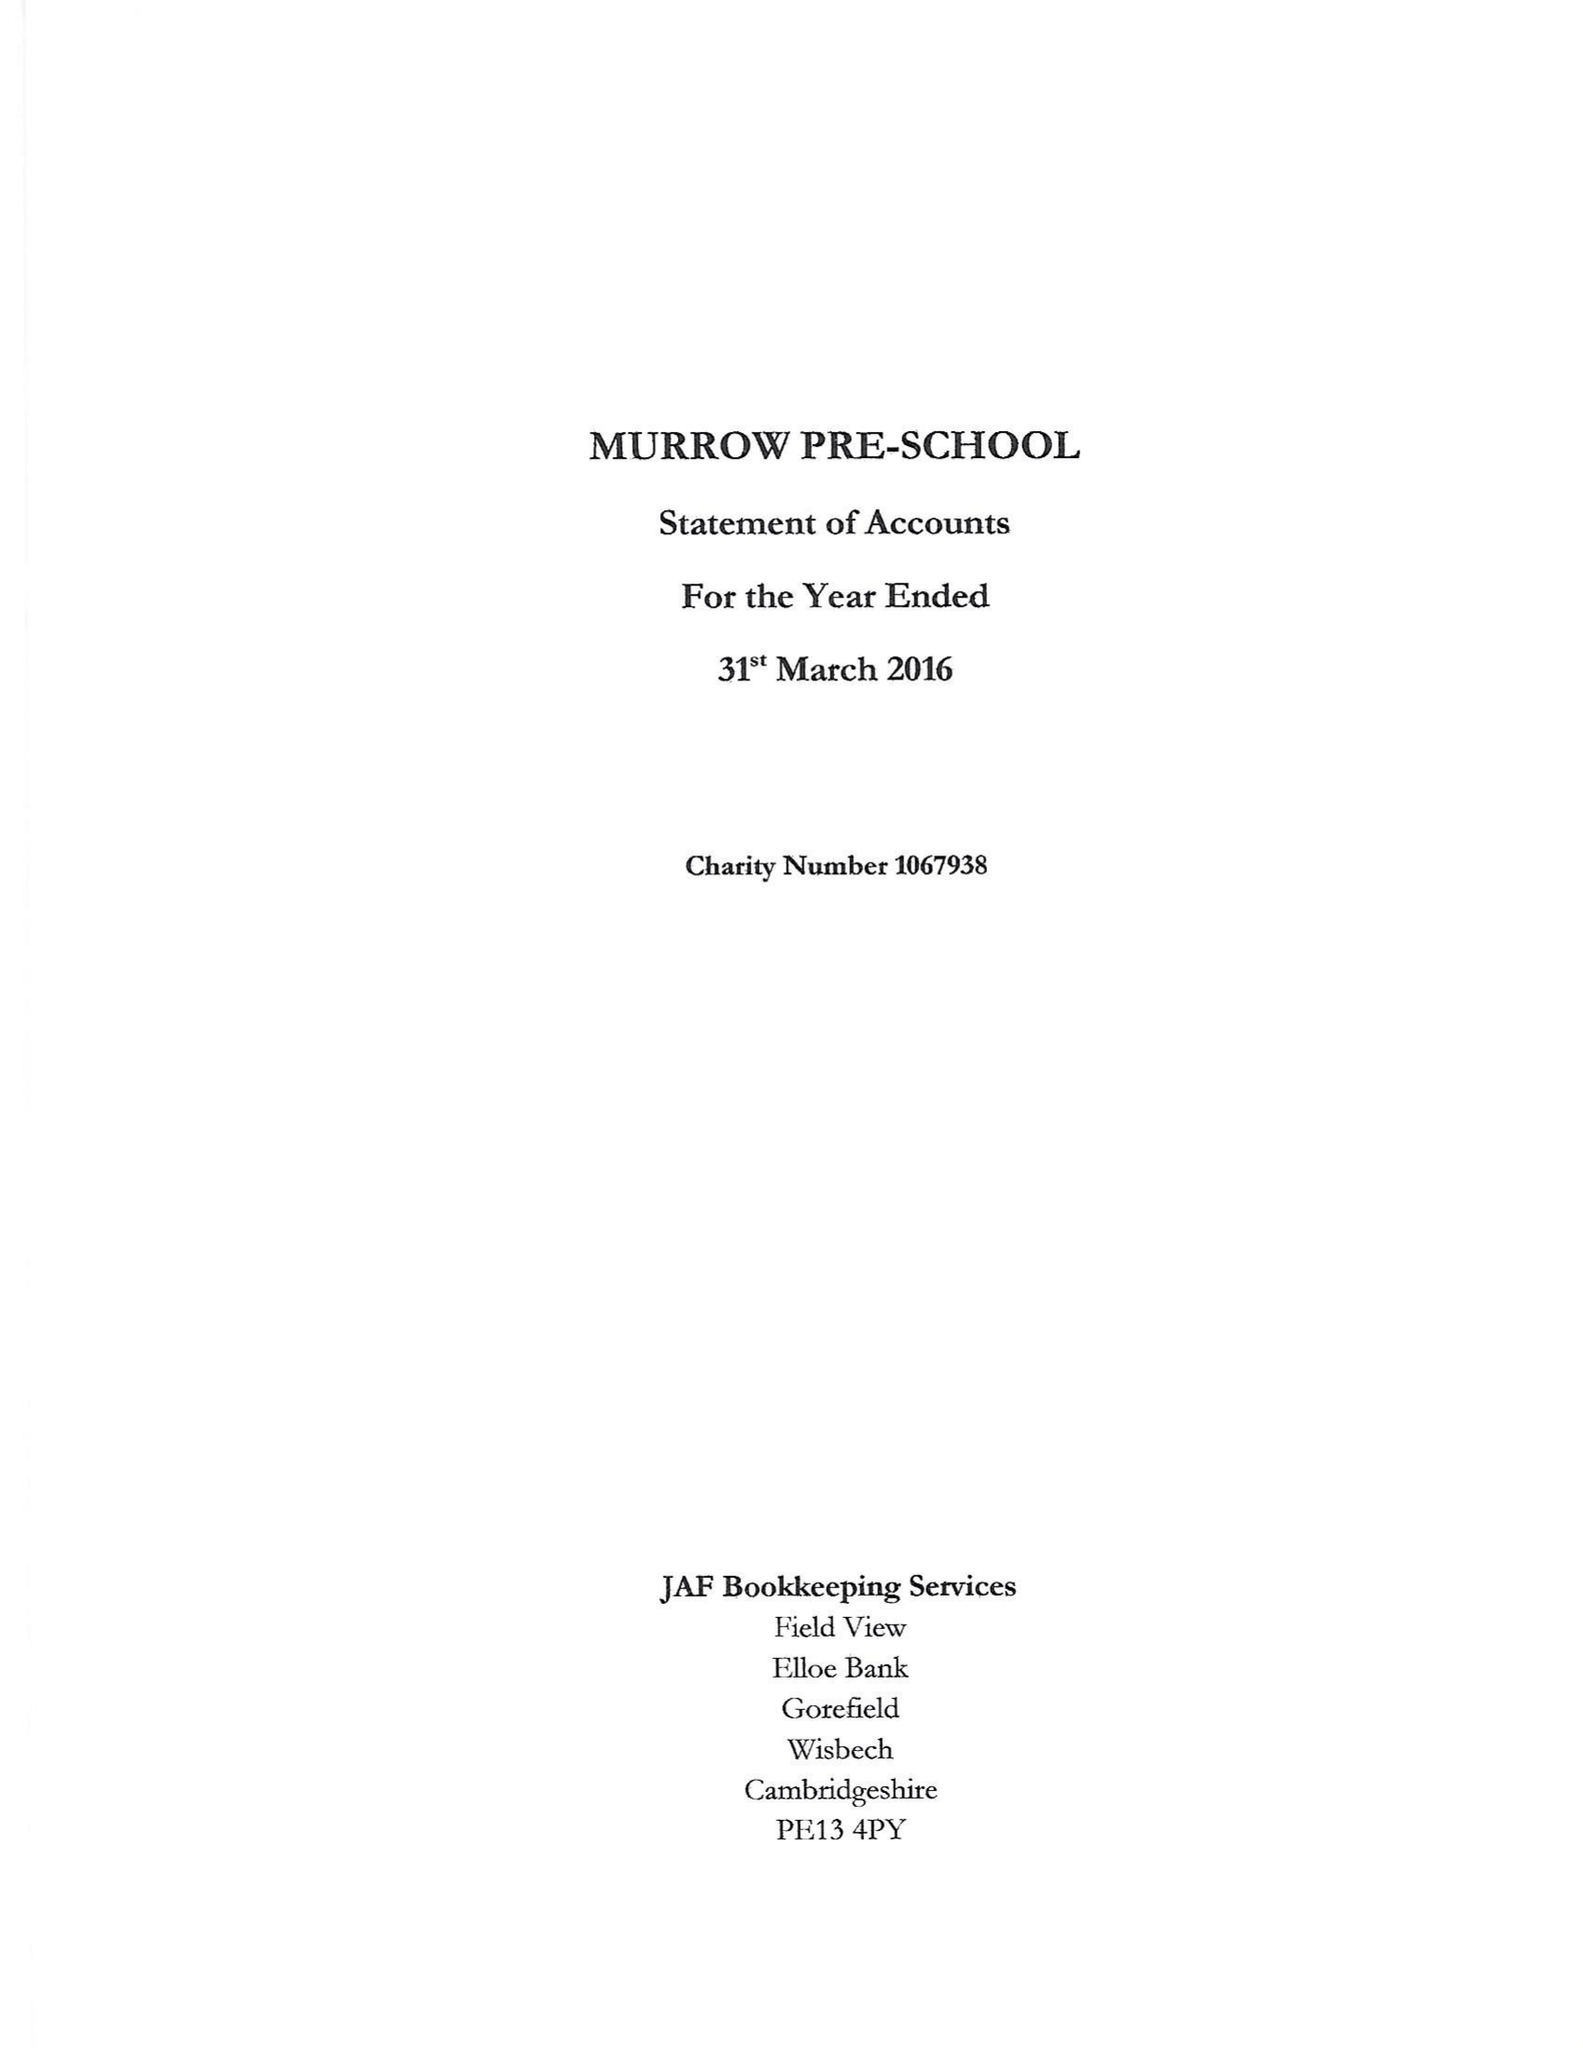What is the value for the address__postcode?
Answer the question using a single word or phrase. PE13 4HD 